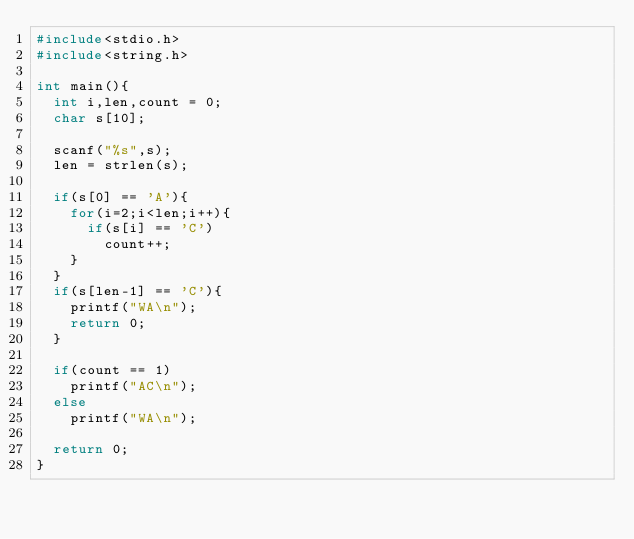<code> <loc_0><loc_0><loc_500><loc_500><_C_>#include<stdio.h>
#include<string.h>

int main(){
  int i,len,count = 0;
  char s[10];

  scanf("%s",s);
  len = strlen(s);

  if(s[0] == 'A'){
    for(i=2;i<len;i++){
      if(s[i] == 'C')
        count++;
    }
  }
  if(s[len-1] == 'C'){
    printf("WA\n");
    return 0;
  }

  if(count == 1)
    printf("AC\n");
  else
    printf("WA\n");

  return 0;
}</code> 